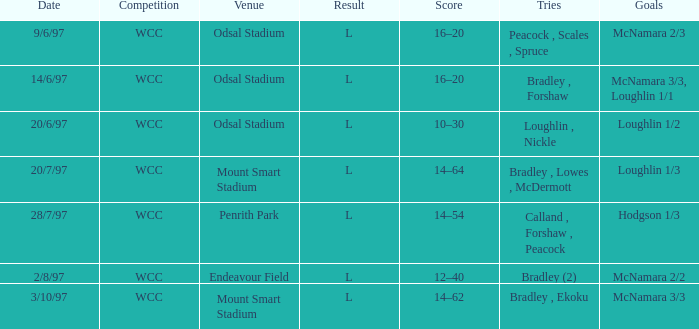What was the tally on 20/6/97? 10–30. 